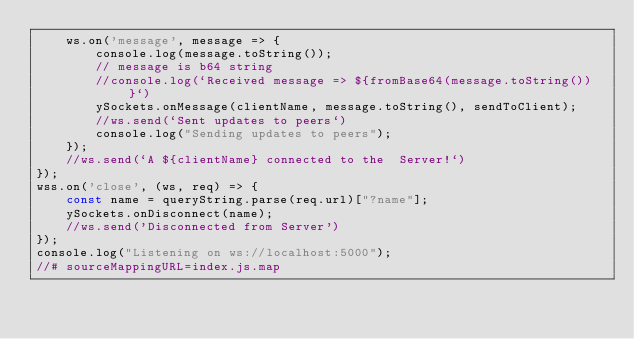Convert code to text. <code><loc_0><loc_0><loc_500><loc_500><_JavaScript_>    ws.on('message', message => {
        console.log(message.toString());
        // message is b64 string
        //console.log(`Received message => ${fromBase64(message.toString())}`)
        ySockets.onMessage(clientName, message.toString(), sendToClient);
        //ws.send(`Sent updates to peers`)
        console.log("Sending updates to peers");
    });
    //ws.send(`A ${clientName} connected to the  Server!`)
});
wss.on('close', (ws, req) => {
    const name = queryString.parse(req.url)["?name"];
    ySockets.onDisconnect(name);
    //ws.send('Disconnected from Server')
});
console.log("Listening on ws://localhost:5000");
//# sourceMappingURL=index.js.map</code> 